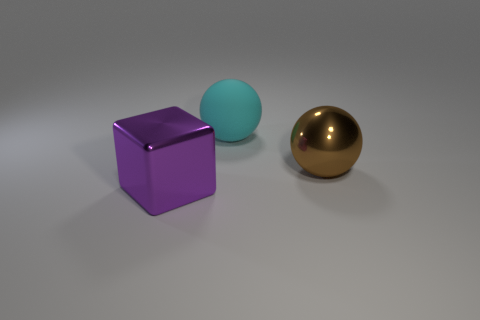What is the material of the big sphere that is behind the large ball to the right of the large cyan thing?
Make the answer very short. Rubber. What number of metal things are small yellow spheres or cubes?
Make the answer very short. 1. Is there any other thing that is the same material as the purple object?
Your answer should be compact. Yes. There is a metallic object in front of the large brown sphere; are there any brown spheres that are in front of it?
Keep it short and to the point. No. What number of things are either spheres that are in front of the matte object or large things right of the big purple cube?
Your response must be concise. 2. Is there any other thing that is the same color as the matte sphere?
Keep it short and to the point. No. There is a big ball that is behind the metal object that is right of the thing left of the big rubber sphere; what color is it?
Provide a succinct answer. Cyan. What size is the metal object that is right of the metal object left of the big matte ball?
Give a very brief answer. Large. What is the material of the thing that is left of the large metal sphere and behind the purple block?
Give a very brief answer. Rubber. Is the size of the purple metallic block the same as the metallic object that is on the right side of the large purple cube?
Your answer should be very brief. Yes. 